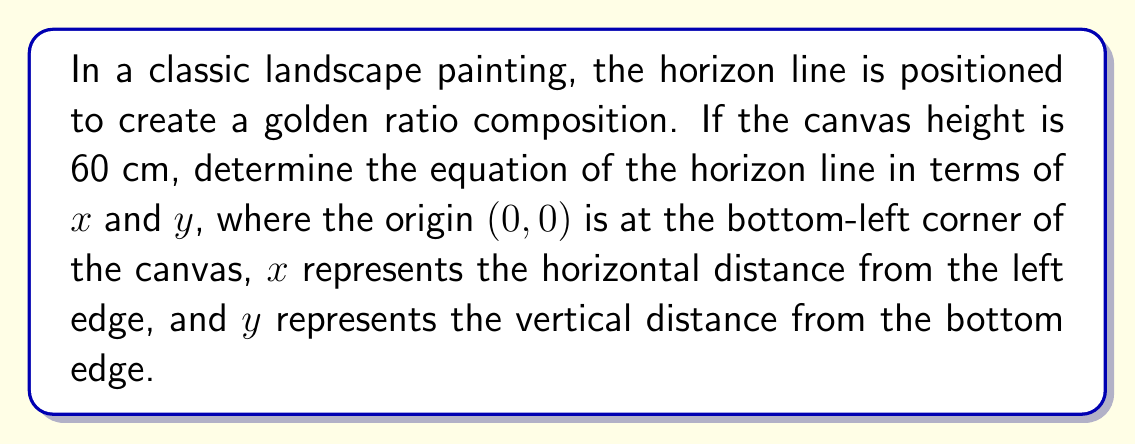Teach me how to tackle this problem. Let's approach this step-by-step:

1) The golden ratio, denoted by φ (phi), is approximately 1.618034. In a composition, this means the ratio of the larger part to the smaller part is φ.

2) For a canvas height of 60 cm, we need to divide it according to the golden ratio:
   
   $$\frac{\text{larger part}}{\text{smaller part}} = φ ≈ 1.618034$$

3) Let's call the smaller part y. Then the larger part is (60 - y).
   
   $$\frac{60 - y}{y} = 1.618034$$

4) Solving this equation:
   
   $$60 - y = 1.618034y$$
   $$60 = 2.618034y$$
   $$y = \frac{60}{2.618034} ≈ 22.92 \text{ cm}$$

5) This means the horizon line should be approximately 22.92 cm from the bottom of the canvas.

6) In the coordinate system described, this horizontal line can be represented by the equation:

   $$y = 22.92$$

7) This is a horizontal line, so its slope is 0 and it's parallel to the x-axis.

8) The general form of a line equation is $y = mx + b$, where m is the slope and b is the y-intercept.

9) In this case, m = 0 and b = 22.92.

Therefore, the equation of the horizon line is:

$$y = 0x + 22.92$$ or simply $$y = 22.92$$

This line divides the canvas into two parts with a ratio of approximately 1.618034 : 1, representing the golden ratio in the painting's composition.

[asy]
size(200,120);
draw((0,0)--(100,0)--(100,60)--(0,60)--cycle);
draw((0,22.92)--(100,22.92),blue);
label("60 cm",(-5,30),W);
label("22.92 cm",(-5,11.46),W);
label("37.08 cm",(-5,41.46),W);
label("Horizon Line",(50,25),N,blue);
[/asy]
Answer: $$y = 22.92$$ 